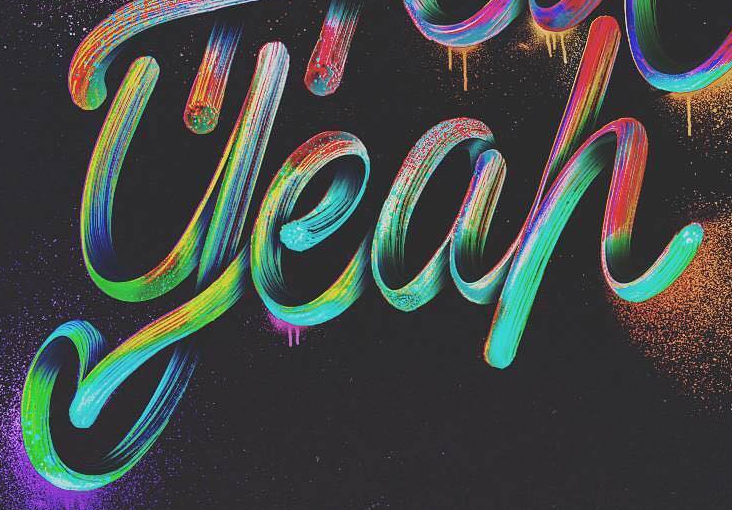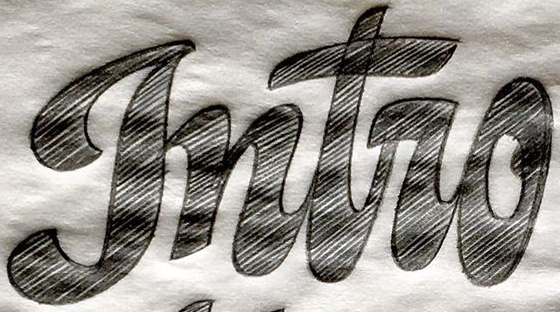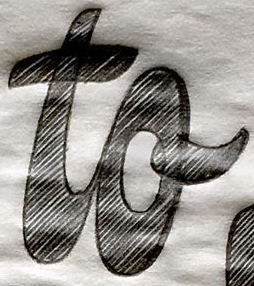What text appears in these images from left to right, separated by a semicolon? yeah; gntro; to 